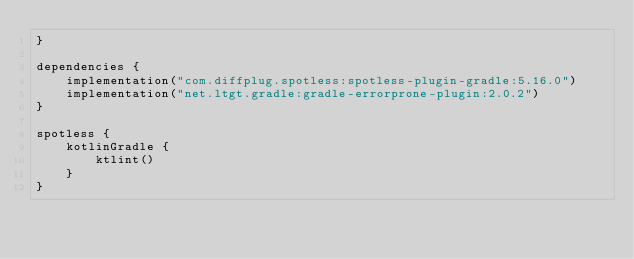Convert code to text. <code><loc_0><loc_0><loc_500><loc_500><_Kotlin_>}

dependencies {
    implementation("com.diffplug.spotless:spotless-plugin-gradle:5.16.0")
    implementation("net.ltgt.gradle:gradle-errorprone-plugin:2.0.2")
}

spotless {
    kotlinGradle {
        ktlint()
    }
}
</code> 